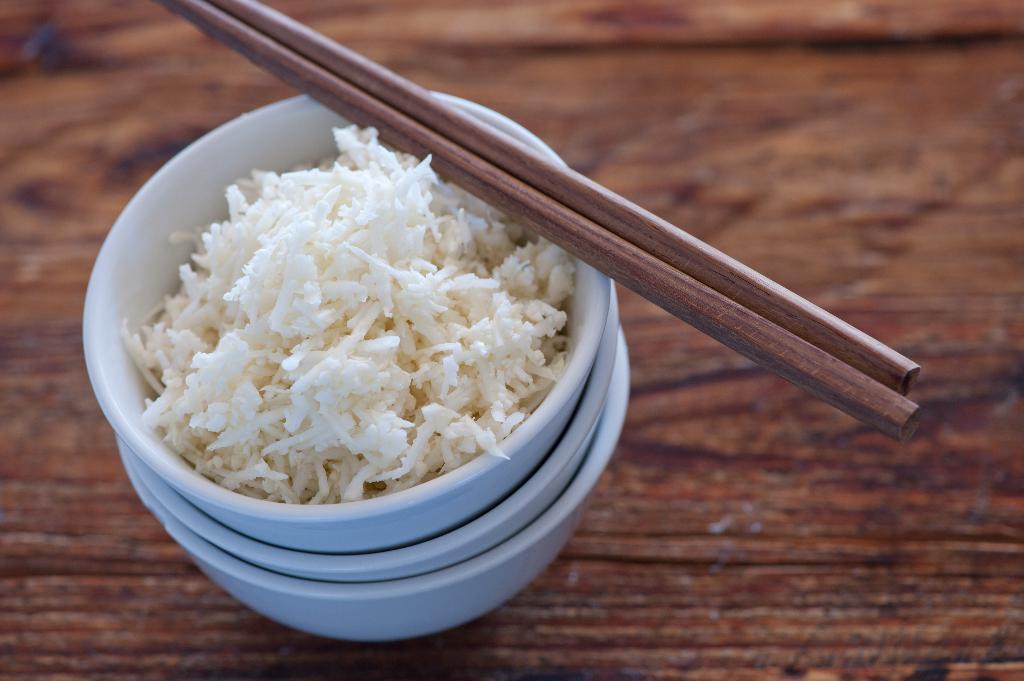Can you describe this image briefly? In this image we can see three blue color bowls and rice in it. These are the wooden chopsticks. They are placed on the wooden table. 